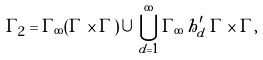Convert formula to latex. <formula><loc_0><loc_0><loc_500><loc_500>\Gamma _ { 2 } = \Gamma _ { \infty } ( \Gamma \times \Gamma ) \, \cup \, \bigcup _ { d = 1 } ^ { \infty } \Gamma _ { \infty } \, h _ { d } ^ { \prime } \, \Gamma \times \Gamma ,</formula> 